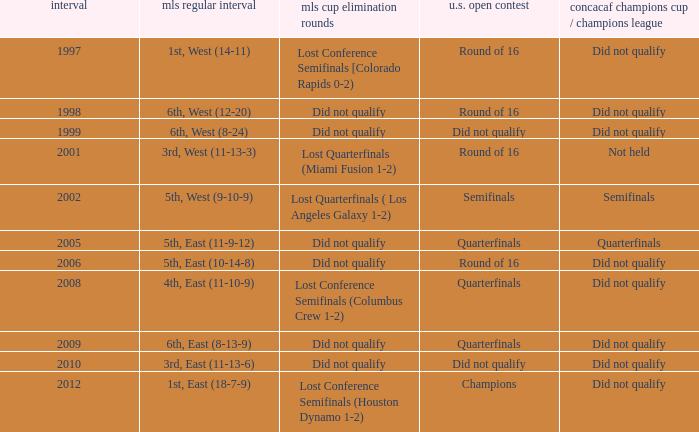How did the team place when they did not qualify for the Concaf Champions Cup but made it to Round of 16 in the U.S. Open Cup? Lost Conference Semifinals [Colorado Rapids 0-2), Did not qualify, Did not qualify. 